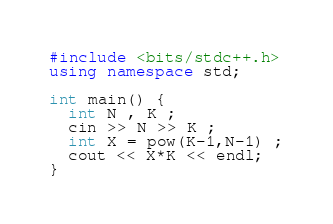Convert code to text. <code><loc_0><loc_0><loc_500><loc_500><_C++_>#include <bits/stdc++.h>
using namespace std;

int main() {
  int N , K ;
  cin >> N >> K ;
  int X = pow(K-1,N-1) ;
  cout << X*K << endl;
}

</code> 